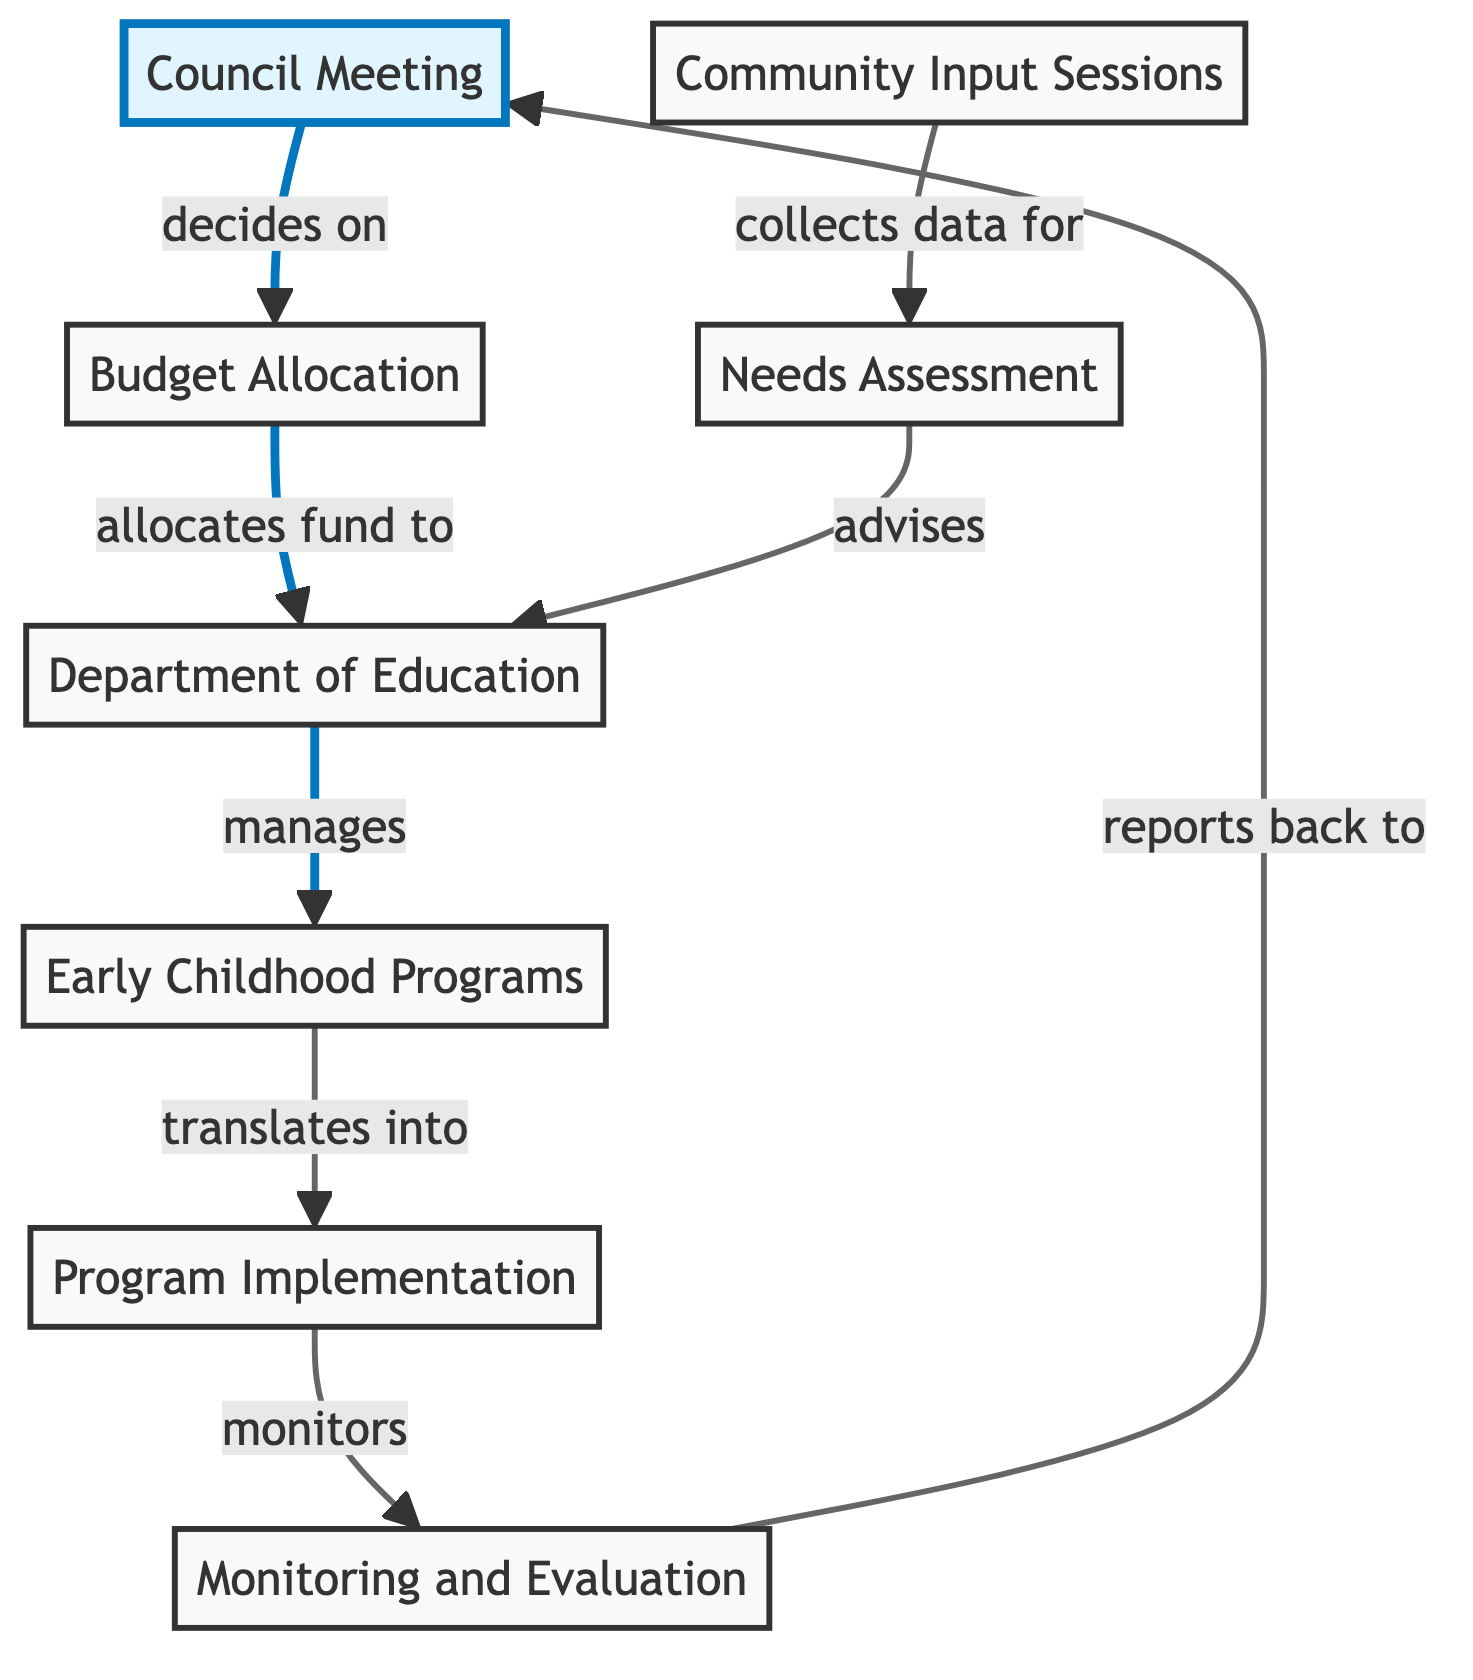What is the first node in the resource distribution pathway? The first node in the diagram is "Council Meeting", which initiates the process by deciding on budget allocation.
Answer: Council Meeting How many nodes are present in the diagram? By counting the distinct representations of entities in the diagram, we have a total of eight nodes representing different stages of the resource distribution pathway.
Answer: 8 What does the "Budget Allocation" node do? The "Budget Allocation" node plays the role of allocating funds to the "Department of Education" following a decision made in the "Council Meeting".
Answer: allocates fund to What is the relationship between "Needs Assessment" and "Department of Education"? The "Needs Assessment" node advises the "Department of Education" using the data collected from "Community Input Sessions", thus providing insights for further actions.
Answer: advises Which node directly follows "Program Implementation"? After the "Program Implementation" node, the next node in the pathway is "Monitoring and Evaluation", which ensures that the programs are effectively managed and evaluated.
Answer: Monitoring and Evaluation What is the outcome of "Monitoring and Evaluation"? The final outcome of the "Monitoring and Evaluation" is to present findings back to the "Council Meeting", allowing for informed decisions in future planning.
Answer: reports back to How does "Community Input Sessions" influence the diagram? The "Community Input Sessions" influence the diagram by collecting data for the "Needs Assessment", which is crucial for advising the "Department of Education" on the needs for early childhood programs.
Answer: collects data for What stage comes after "Early Childhood Programs"? Following "Early Childhood Programs", the next stage is "Program Implementation", indicating the translation of plans into actionable programs.
Answer: Program Implementation Which node is managed by the "Department of Education"? The "Department of Education" manages the node "Early Childhood Programs", indicating a direct responsibility for oversight and coordination of these initiatives.
Answer: Early Childhood Programs 